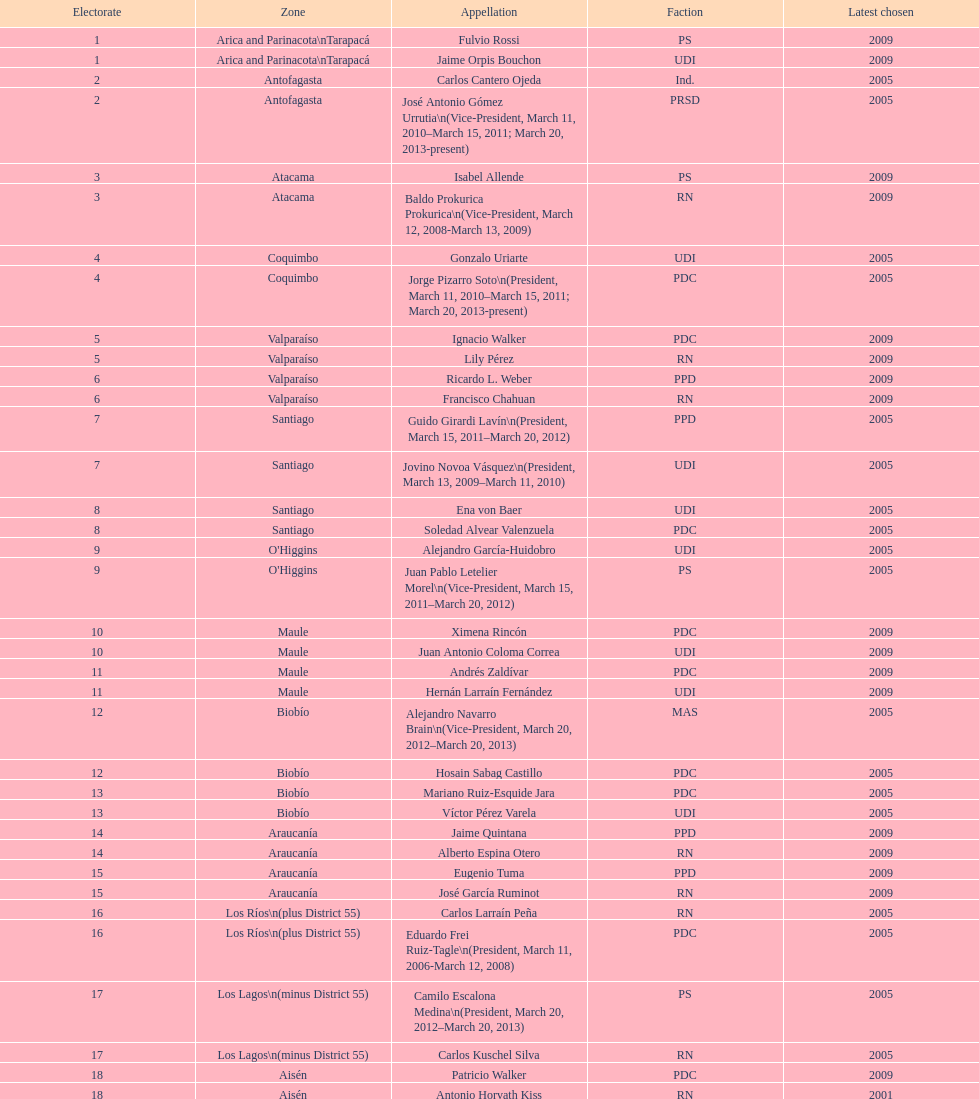What was the duration of baldo prokurica's tenure as vice-president? 1 year. 